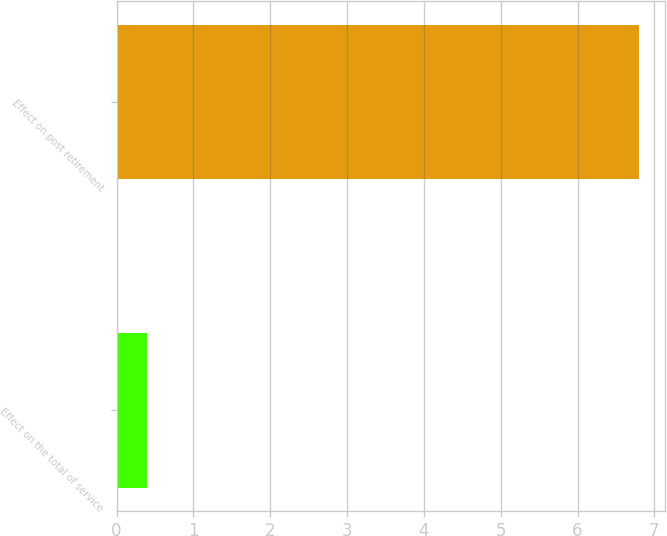Convert chart to OTSL. <chart><loc_0><loc_0><loc_500><loc_500><bar_chart><fcel>Effect on the total of service<fcel>Effect on post retirement<nl><fcel>0.4<fcel>6.8<nl></chart> 